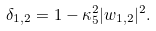<formula> <loc_0><loc_0><loc_500><loc_500>\delta _ { 1 , 2 } = 1 - \kappa _ { 5 } ^ { 2 } | w _ { 1 , 2 } | ^ { 2 } .</formula> 